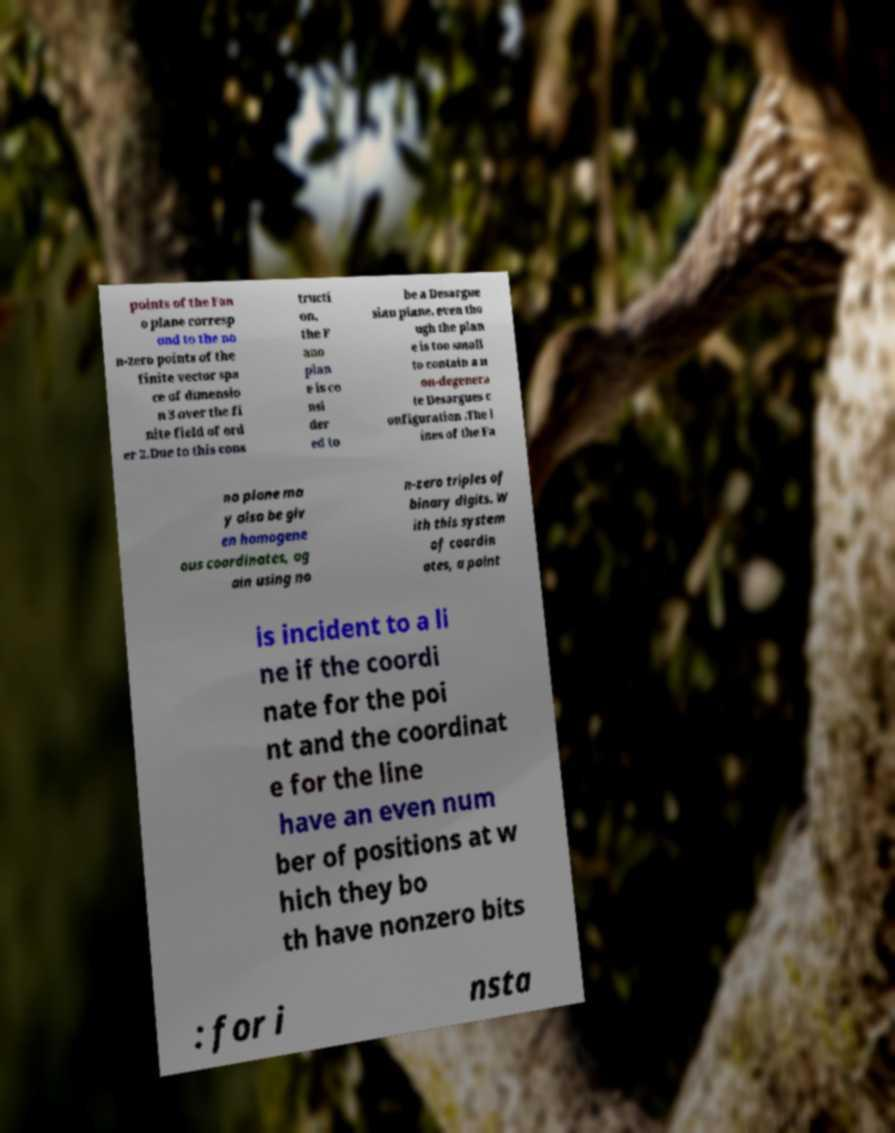I need the written content from this picture converted into text. Can you do that? points of the Fan o plane corresp ond to the no n-zero points of the finite vector spa ce of dimensio n 3 over the fi nite field of ord er 2.Due to this cons tructi on, the F ano plan e is co nsi der ed to be a Desargue sian plane, even tho ugh the plan e is too small to contain a n on-degenera te Desargues c onfiguration .The l ines of the Fa no plane ma y also be giv en homogene ous coordinates, ag ain using no n-zero triples of binary digits. W ith this system of coordin ates, a point is incident to a li ne if the coordi nate for the poi nt and the coordinat e for the line have an even num ber of positions at w hich they bo th have nonzero bits : for i nsta 